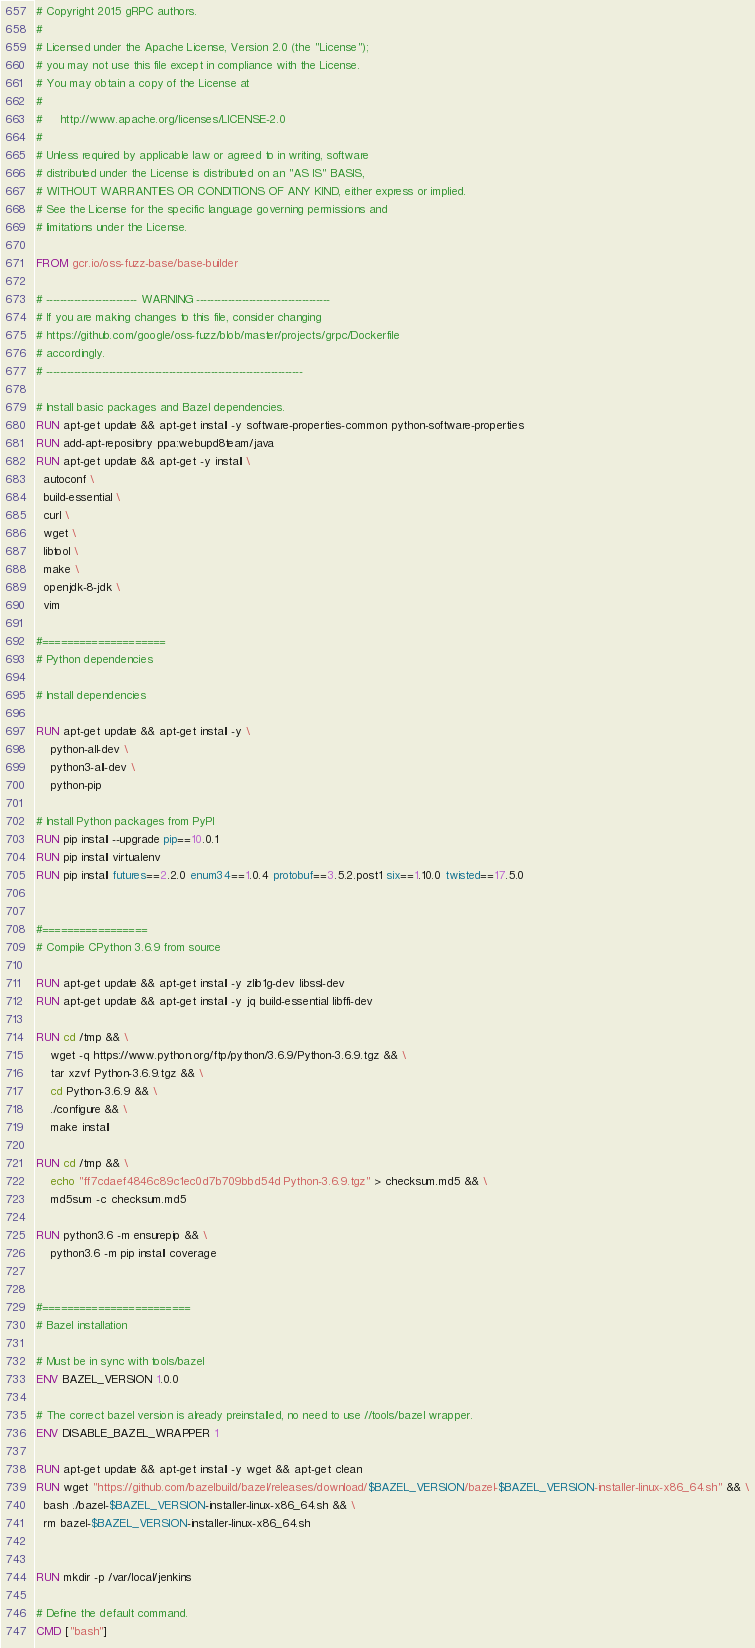Convert code to text. <code><loc_0><loc_0><loc_500><loc_500><_Dockerfile_># Copyright 2015 gRPC authors.
#
# Licensed under the Apache License, Version 2.0 (the "License");
# you may not use this file except in compliance with the License.
# You may obtain a copy of the License at
#
#     http://www.apache.org/licenses/LICENSE-2.0
#
# Unless required by applicable law or agreed to in writing, software
# distributed under the License is distributed on an "AS IS" BASIS,
# WITHOUT WARRANTIES OR CONDITIONS OF ANY KIND, either express or implied.
# See the License for the specific language governing permissions and
# limitations under the License.

FROM gcr.io/oss-fuzz-base/base-builder

# -------------------------- WARNING --------------------------------------
# If you are making changes to this file, consider changing
# https://github.com/google/oss-fuzz/blob/master/projects/grpc/Dockerfile
# accordingly.
# -------------------------------------------------------------------------

# Install basic packages and Bazel dependencies.
RUN apt-get update && apt-get install -y software-properties-common python-software-properties
RUN add-apt-repository ppa:webupd8team/java
RUN apt-get update && apt-get -y install \
  autoconf \
  build-essential \
  curl \
  wget \
  libtool \
  make \
  openjdk-8-jdk \
  vim

#====================
# Python dependencies

# Install dependencies

RUN apt-get update && apt-get install -y \
    python-all-dev \
    python3-all-dev \
    python-pip

# Install Python packages from PyPI
RUN pip install --upgrade pip==10.0.1
RUN pip install virtualenv
RUN pip install futures==2.2.0 enum34==1.0.4 protobuf==3.5.2.post1 six==1.10.0 twisted==17.5.0


#=================
# Compile CPython 3.6.9 from source

RUN apt-get update && apt-get install -y zlib1g-dev libssl-dev
RUN apt-get update && apt-get install -y jq build-essential libffi-dev

RUN cd /tmp && \
    wget -q https://www.python.org/ftp/python/3.6.9/Python-3.6.9.tgz && \
    tar xzvf Python-3.6.9.tgz && \
    cd Python-3.6.9 && \
    ./configure && \
    make install

RUN cd /tmp && \
    echo "ff7cdaef4846c89c1ec0d7b709bbd54d Python-3.6.9.tgz" > checksum.md5 && \
    md5sum -c checksum.md5

RUN python3.6 -m ensurepip && \
    python3.6 -m pip install coverage


#========================
# Bazel installation

# Must be in sync with tools/bazel
ENV BAZEL_VERSION 1.0.0

# The correct bazel version is already preinstalled, no need to use //tools/bazel wrapper.
ENV DISABLE_BAZEL_WRAPPER 1

RUN apt-get update && apt-get install -y wget && apt-get clean
RUN wget "https://github.com/bazelbuild/bazel/releases/download/$BAZEL_VERSION/bazel-$BAZEL_VERSION-installer-linux-x86_64.sh" && \
  bash ./bazel-$BAZEL_VERSION-installer-linux-x86_64.sh && \
  rm bazel-$BAZEL_VERSION-installer-linux-x86_64.sh


RUN mkdir -p /var/local/jenkins

# Define the default command.
CMD ["bash"]
</code> 